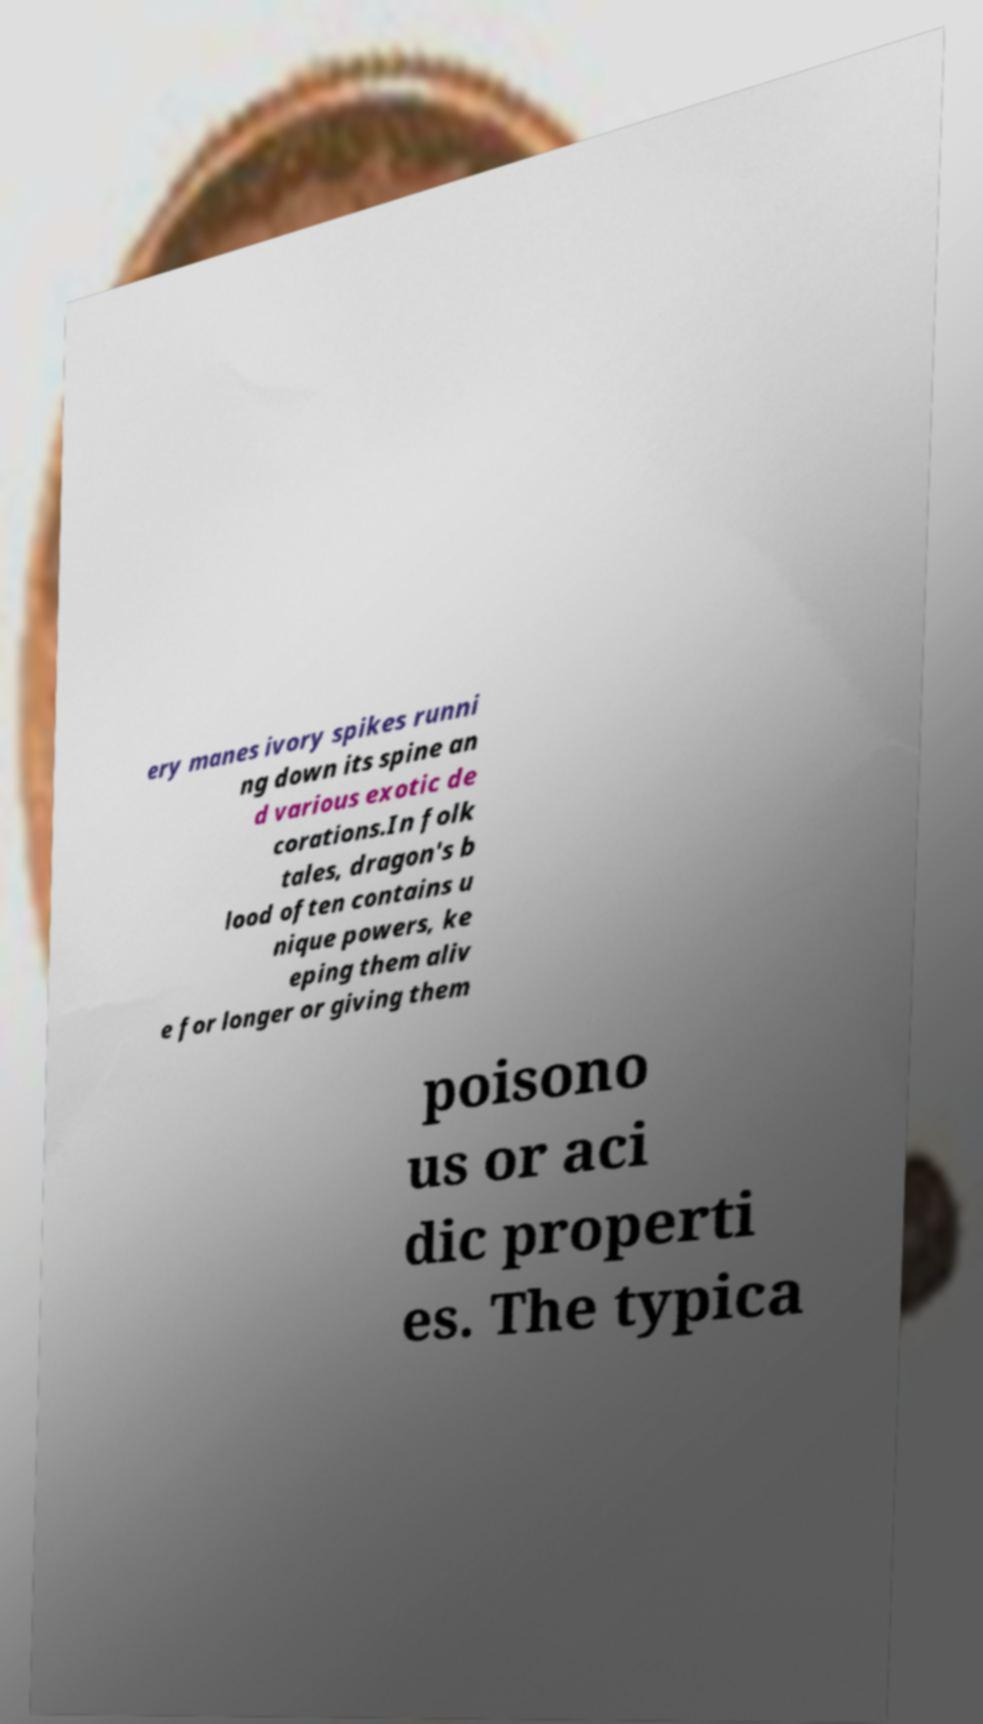Could you assist in decoding the text presented in this image and type it out clearly? ery manes ivory spikes runni ng down its spine an d various exotic de corations.In folk tales, dragon's b lood often contains u nique powers, ke eping them aliv e for longer or giving them poisono us or aci dic properti es. The typica 